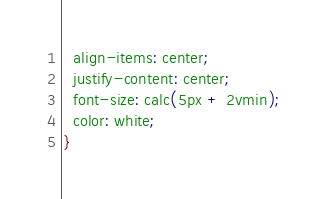Convert code to text. <code><loc_0><loc_0><loc_500><loc_500><_CSS_>  align-items: center;
  justify-content: center;
  font-size: calc(5px + 2vmin);
  color: white;
}




</code> 